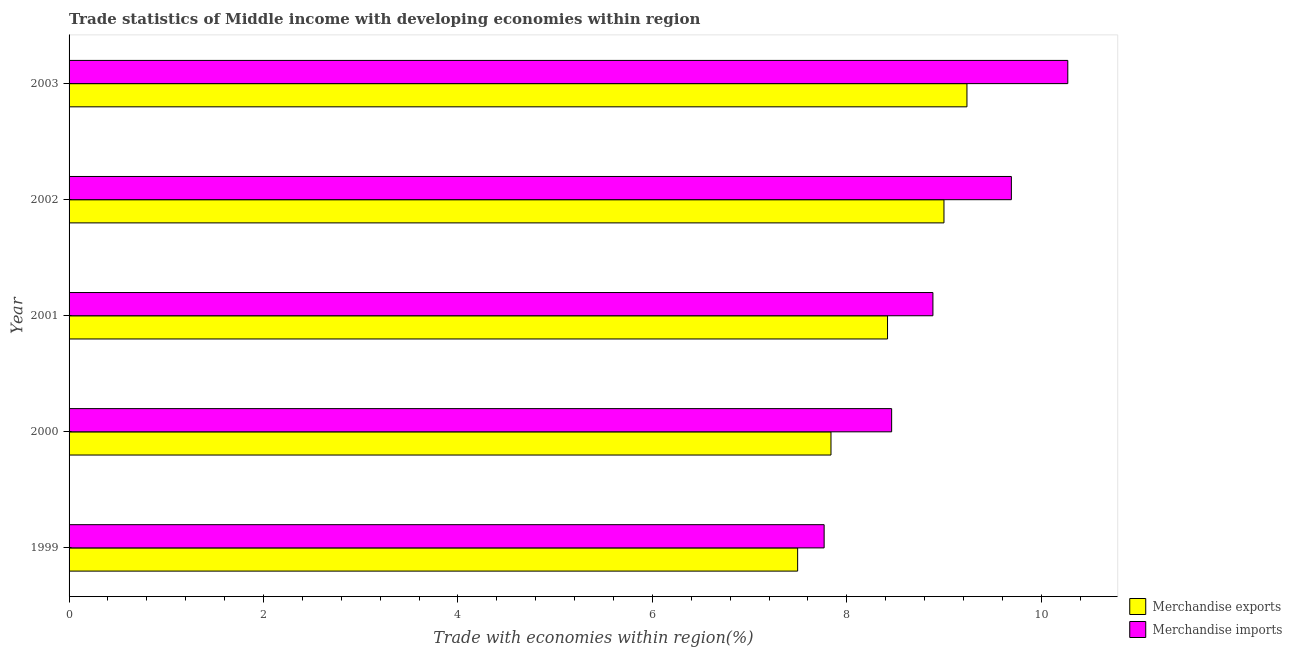How many different coloured bars are there?
Make the answer very short. 2. How many bars are there on the 5th tick from the top?
Your response must be concise. 2. How many bars are there on the 3rd tick from the bottom?
Your answer should be very brief. 2. In how many cases, is the number of bars for a given year not equal to the number of legend labels?
Ensure brevity in your answer.  0. What is the merchandise imports in 1999?
Keep it short and to the point. 7.77. Across all years, what is the maximum merchandise imports?
Offer a very short reply. 10.27. Across all years, what is the minimum merchandise exports?
Your answer should be very brief. 7.49. In which year was the merchandise exports maximum?
Give a very brief answer. 2003. In which year was the merchandise exports minimum?
Your answer should be compact. 1999. What is the total merchandise exports in the graph?
Ensure brevity in your answer.  41.99. What is the difference between the merchandise exports in 2000 and that in 2003?
Offer a very short reply. -1.4. What is the difference between the merchandise exports in 1999 and the merchandise imports in 2001?
Offer a terse response. -1.39. What is the average merchandise imports per year?
Your answer should be compact. 9.02. In the year 2001, what is the difference between the merchandise exports and merchandise imports?
Provide a short and direct response. -0.47. In how many years, is the merchandise exports greater than 4 %?
Your response must be concise. 5. What is the ratio of the merchandise imports in 1999 to that in 2002?
Your answer should be compact. 0.8. Is the merchandise imports in 2000 less than that in 2001?
Give a very brief answer. Yes. Is the difference between the merchandise imports in 2000 and 2001 greater than the difference between the merchandise exports in 2000 and 2001?
Provide a short and direct response. Yes. What is the difference between the highest and the second highest merchandise exports?
Your response must be concise. 0.24. What is the difference between the highest and the lowest merchandise exports?
Offer a very short reply. 1.74. What does the 1st bar from the top in 2002 represents?
Provide a succinct answer. Merchandise imports. What does the 2nd bar from the bottom in 2003 represents?
Offer a very short reply. Merchandise imports. How many bars are there?
Offer a very short reply. 10. Does the graph contain grids?
Your answer should be very brief. No. How are the legend labels stacked?
Provide a succinct answer. Vertical. What is the title of the graph?
Keep it short and to the point. Trade statistics of Middle income with developing economies within region. What is the label or title of the X-axis?
Your answer should be very brief. Trade with economies within region(%). What is the Trade with economies within region(%) of Merchandise exports in 1999?
Provide a succinct answer. 7.49. What is the Trade with economies within region(%) of Merchandise imports in 1999?
Your response must be concise. 7.77. What is the Trade with economies within region(%) of Merchandise exports in 2000?
Your response must be concise. 7.84. What is the Trade with economies within region(%) of Merchandise imports in 2000?
Offer a very short reply. 8.46. What is the Trade with economies within region(%) of Merchandise exports in 2001?
Give a very brief answer. 8.42. What is the Trade with economies within region(%) of Merchandise imports in 2001?
Give a very brief answer. 8.89. What is the Trade with economies within region(%) of Merchandise exports in 2002?
Your answer should be very brief. 9. What is the Trade with economies within region(%) of Merchandise imports in 2002?
Your answer should be very brief. 9.69. What is the Trade with economies within region(%) in Merchandise exports in 2003?
Keep it short and to the point. 9.24. What is the Trade with economies within region(%) in Merchandise imports in 2003?
Provide a short and direct response. 10.27. Across all years, what is the maximum Trade with economies within region(%) in Merchandise exports?
Offer a very short reply. 9.24. Across all years, what is the maximum Trade with economies within region(%) in Merchandise imports?
Give a very brief answer. 10.27. Across all years, what is the minimum Trade with economies within region(%) in Merchandise exports?
Provide a short and direct response. 7.49. Across all years, what is the minimum Trade with economies within region(%) in Merchandise imports?
Ensure brevity in your answer.  7.77. What is the total Trade with economies within region(%) in Merchandise exports in the graph?
Offer a very short reply. 41.99. What is the total Trade with economies within region(%) in Merchandise imports in the graph?
Give a very brief answer. 45.08. What is the difference between the Trade with economies within region(%) of Merchandise exports in 1999 and that in 2000?
Keep it short and to the point. -0.34. What is the difference between the Trade with economies within region(%) of Merchandise imports in 1999 and that in 2000?
Give a very brief answer. -0.69. What is the difference between the Trade with economies within region(%) in Merchandise exports in 1999 and that in 2001?
Give a very brief answer. -0.92. What is the difference between the Trade with economies within region(%) in Merchandise imports in 1999 and that in 2001?
Give a very brief answer. -1.12. What is the difference between the Trade with economies within region(%) of Merchandise exports in 1999 and that in 2002?
Provide a short and direct response. -1.51. What is the difference between the Trade with economies within region(%) of Merchandise imports in 1999 and that in 2002?
Make the answer very short. -1.93. What is the difference between the Trade with economies within region(%) of Merchandise exports in 1999 and that in 2003?
Keep it short and to the point. -1.74. What is the difference between the Trade with economies within region(%) in Merchandise imports in 1999 and that in 2003?
Keep it short and to the point. -2.51. What is the difference between the Trade with economies within region(%) in Merchandise exports in 2000 and that in 2001?
Keep it short and to the point. -0.58. What is the difference between the Trade with economies within region(%) of Merchandise imports in 2000 and that in 2001?
Offer a terse response. -0.42. What is the difference between the Trade with economies within region(%) of Merchandise exports in 2000 and that in 2002?
Ensure brevity in your answer.  -1.16. What is the difference between the Trade with economies within region(%) of Merchandise imports in 2000 and that in 2002?
Make the answer very short. -1.23. What is the difference between the Trade with economies within region(%) of Merchandise exports in 2000 and that in 2003?
Keep it short and to the point. -1.4. What is the difference between the Trade with economies within region(%) of Merchandise imports in 2000 and that in 2003?
Give a very brief answer. -1.81. What is the difference between the Trade with economies within region(%) of Merchandise exports in 2001 and that in 2002?
Your response must be concise. -0.58. What is the difference between the Trade with economies within region(%) in Merchandise imports in 2001 and that in 2002?
Ensure brevity in your answer.  -0.81. What is the difference between the Trade with economies within region(%) in Merchandise exports in 2001 and that in 2003?
Make the answer very short. -0.82. What is the difference between the Trade with economies within region(%) of Merchandise imports in 2001 and that in 2003?
Your response must be concise. -1.39. What is the difference between the Trade with economies within region(%) of Merchandise exports in 2002 and that in 2003?
Your response must be concise. -0.24. What is the difference between the Trade with economies within region(%) in Merchandise imports in 2002 and that in 2003?
Offer a very short reply. -0.58. What is the difference between the Trade with economies within region(%) of Merchandise exports in 1999 and the Trade with economies within region(%) of Merchandise imports in 2000?
Your answer should be very brief. -0.97. What is the difference between the Trade with economies within region(%) of Merchandise exports in 1999 and the Trade with economies within region(%) of Merchandise imports in 2001?
Provide a short and direct response. -1.39. What is the difference between the Trade with economies within region(%) in Merchandise exports in 1999 and the Trade with economies within region(%) in Merchandise imports in 2002?
Offer a terse response. -2.2. What is the difference between the Trade with economies within region(%) of Merchandise exports in 1999 and the Trade with economies within region(%) of Merchandise imports in 2003?
Offer a very short reply. -2.78. What is the difference between the Trade with economies within region(%) in Merchandise exports in 2000 and the Trade with economies within region(%) in Merchandise imports in 2001?
Offer a very short reply. -1.05. What is the difference between the Trade with economies within region(%) of Merchandise exports in 2000 and the Trade with economies within region(%) of Merchandise imports in 2002?
Keep it short and to the point. -1.86. What is the difference between the Trade with economies within region(%) of Merchandise exports in 2000 and the Trade with economies within region(%) of Merchandise imports in 2003?
Your response must be concise. -2.44. What is the difference between the Trade with economies within region(%) in Merchandise exports in 2001 and the Trade with economies within region(%) in Merchandise imports in 2002?
Offer a terse response. -1.27. What is the difference between the Trade with economies within region(%) of Merchandise exports in 2001 and the Trade with economies within region(%) of Merchandise imports in 2003?
Your answer should be compact. -1.85. What is the difference between the Trade with economies within region(%) of Merchandise exports in 2002 and the Trade with economies within region(%) of Merchandise imports in 2003?
Ensure brevity in your answer.  -1.27. What is the average Trade with economies within region(%) in Merchandise exports per year?
Your response must be concise. 8.4. What is the average Trade with economies within region(%) of Merchandise imports per year?
Make the answer very short. 9.02. In the year 1999, what is the difference between the Trade with economies within region(%) in Merchandise exports and Trade with economies within region(%) in Merchandise imports?
Give a very brief answer. -0.27. In the year 2000, what is the difference between the Trade with economies within region(%) in Merchandise exports and Trade with economies within region(%) in Merchandise imports?
Give a very brief answer. -0.62. In the year 2001, what is the difference between the Trade with economies within region(%) in Merchandise exports and Trade with economies within region(%) in Merchandise imports?
Your response must be concise. -0.47. In the year 2002, what is the difference between the Trade with economies within region(%) of Merchandise exports and Trade with economies within region(%) of Merchandise imports?
Offer a very short reply. -0.69. In the year 2003, what is the difference between the Trade with economies within region(%) of Merchandise exports and Trade with economies within region(%) of Merchandise imports?
Offer a very short reply. -1.04. What is the ratio of the Trade with economies within region(%) in Merchandise exports in 1999 to that in 2000?
Your answer should be compact. 0.96. What is the ratio of the Trade with economies within region(%) in Merchandise imports in 1999 to that in 2000?
Make the answer very short. 0.92. What is the ratio of the Trade with economies within region(%) of Merchandise exports in 1999 to that in 2001?
Make the answer very short. 0.89. What is the ratio of the Trade with economies within region(%) of Merchandise imports in 1999 to that in 2001?
Offer a terse response. 0.87. What is the ratio of the Trade with economies within region(%) of Merchandise exports in 1999 to that in 2002?
Ensure brevity in your answer.  0.83. What is the ratio of the Trade with economies within region(%) in Merchandise imports in 1999 to that in 2002?
Offer a very short reply. 0.8. What is the ratio of the Trade with economies within region(%) in Merchandise exports in 1999 to that in 2003?
Your answer should be compact. 0.81. What is the ratio of the Trade with economies within region(%) in Merchandise imports in 1999 to that in 2003?
Offer a very short reply. 0.76. What is the ratio of the Trade with economies within region(%) of Merchandise exports in 2000 to that in 2001?
Your answer should be compact. 0.93. What is the ratio of the Trade with economies within region(%) of Merchandise imports in 2000 to that in 2001?
Keep it short and to the point. 0.95. What is the ratio of the Trade with economies within region(%) of Merchandise exports in 2000 to that in 2002?
Give a very brief answer. 0.87. What is the ratio of the Trade with economies within region(%) in Merchandise imports in 2000 to that in 2002?
Ensure brevity in your answer.  0.87. What is the ratio of the Trade with economies within region(%) of Merchandise exports in 2000 to that in 2003?
Your response must be concise. 0.85. What is the ratio of the Trade with economies within region(%) of Merchandise imports in 2000 to that in 2003?
Give a very brief answer. 0.82. What is the ratio of the Trade with economies within region(%) in Merchandise exports in 2001 to that in 2002?
Ensure brevity in your answer.  0.94. What is the ratio of the Trade with economies within region(%) of Merchandise exports in 2001 to that in 2003?
Ensure brevity in your answer.  0.91. What is the ratio of the Trade with economies within region(%) of Merchandise imports in 2001 to that in 2003?
Provide a succinct answer. 0.86. What is the ratio of the Trade with economies within region(%) of Merchandise exports in 2002 to that in 2003?
Your answer should be very brief. 0.97. What is the ratio of the Trade with economies within region(%) in Merchandise imports in 2002 to that in 2003?
Ensure brevity in your answer.  0.94. What is the difference between the highest and the second highest Trade with economies within region(%) of Merchandise exports?
Offer a terse response. 0.24. What is the difference between the highest and the second highest Trade with economies within region(%) of Merchandise imports?
Make the answer very short. 0.58. What is the difference between the highest and the lowest Trade with economies within region(%) in Merchandise exports?
Give a very brief answer. 1.74. What is the difference between the highest and the lowest Trade with economies within region(%) in Merchandise imports?
Offer a very short reply. 2.51. 